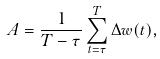Convert formula to latex. <formula><loc_0><loc_0><loc_500><loc_500>A = \frac { 1 } { T - \tau } \sum _ { t = \tau } ^ { T } \Delta w ( t ) ,</formula> 